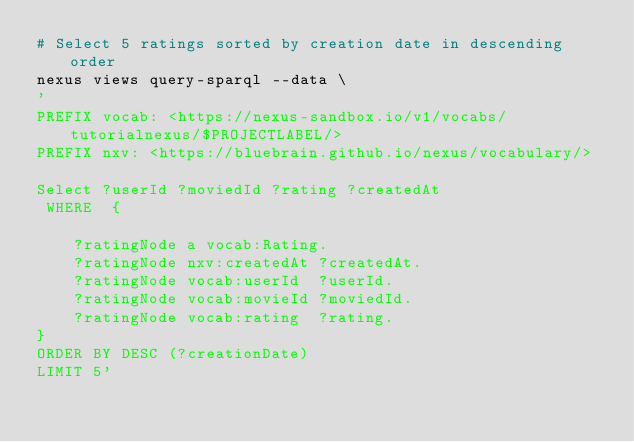<code> <loc_0><loc_0><loc_500><loc_500><_Bash_># Select 5 ratings sorted by creation date in descending order
nexus views query-sparql --data \
'
PREFIX vocab: <https://nexus-sandbox.io/v1/vocabs/tutorialnexus/$PROJECTLABEL/>
PREFIX nxv: <https://bluebrain.github.io/nexus/vocabulary/>

Select ?userId ?moviedId ?rating ?createdAt
 WHERE  {

    ?ratingNode a vocab:Rating.
    ?ratingNode nxv:createdAt ?createdAt.
    ?ratingNode vocab:userId  ?userId.
    ?ratingNode vocab:movieId ?moviedId.
    ?ratingNode vocab:rating  ?rating.
}
ORDER BY DESC (?creationDate)
LIMIT 5'</code> 